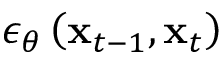<formula> <loc_0><loc_0><loc_500><loc_500>\epsilon _ { \theta } \left ( x _ { t - 1 } , x _ { t } \right )</formula> 